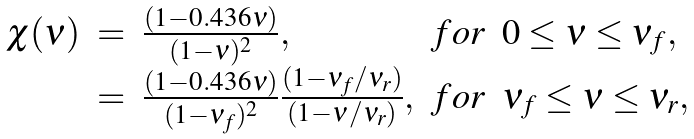<formula> <loc_0><loc_0><loc_500><loc_500>\begin{array} { r c l c l } \chi ( \nu ) & = & \frac { ( 1 - 0 . 4 3 6 \nu ) } { ( 1 - \nu ) ^ { 2 } } , & f o r & 0 \leq \nu \leq \nu _ { f } , \\ & = & \frac { ( 1 - 0 . 4 3 6 \nu ) } { ( 1 - \nu _ { f } ) ^ { 2 } } \frac { ( 1 - \nu _ { f } / \nu _ { r } ) } { ( 1 - \nu / \nu _ { r } ) } , & f o r & \nu _ { f } \leq \nu \leq \nu _ { r } , \end{array}</formula> 